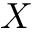Convert formula to latex. <formula><loc_0><loc_0><loc_500><loc_500>X</formula> 